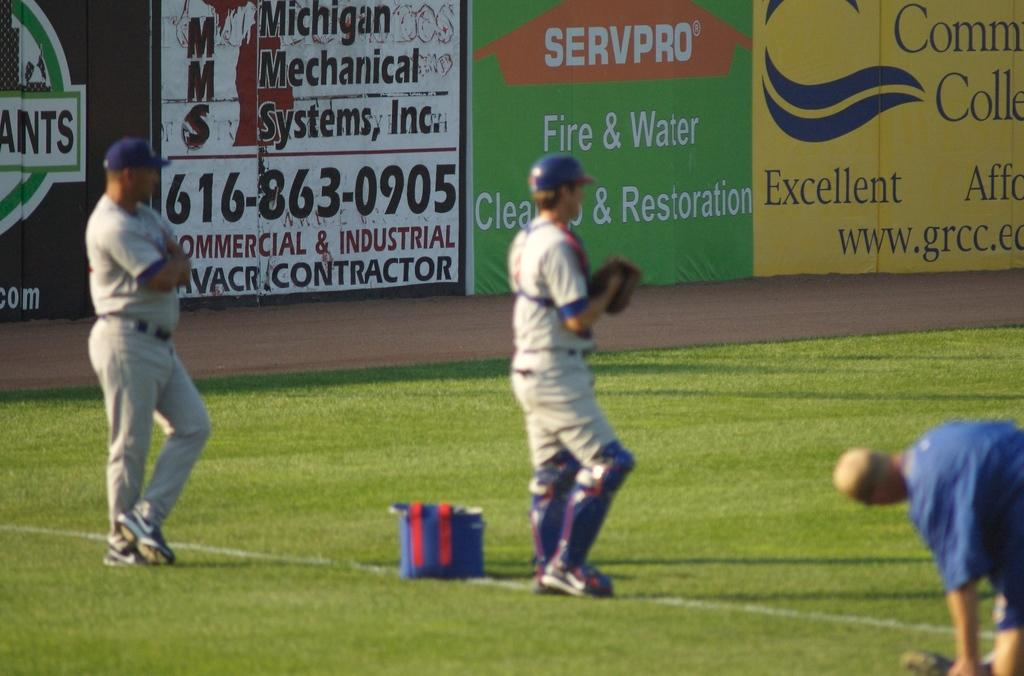<image>
Render a clear and concise summary of the photo. Baseball players stand on a field of which Servpro is one of the sponsors. 